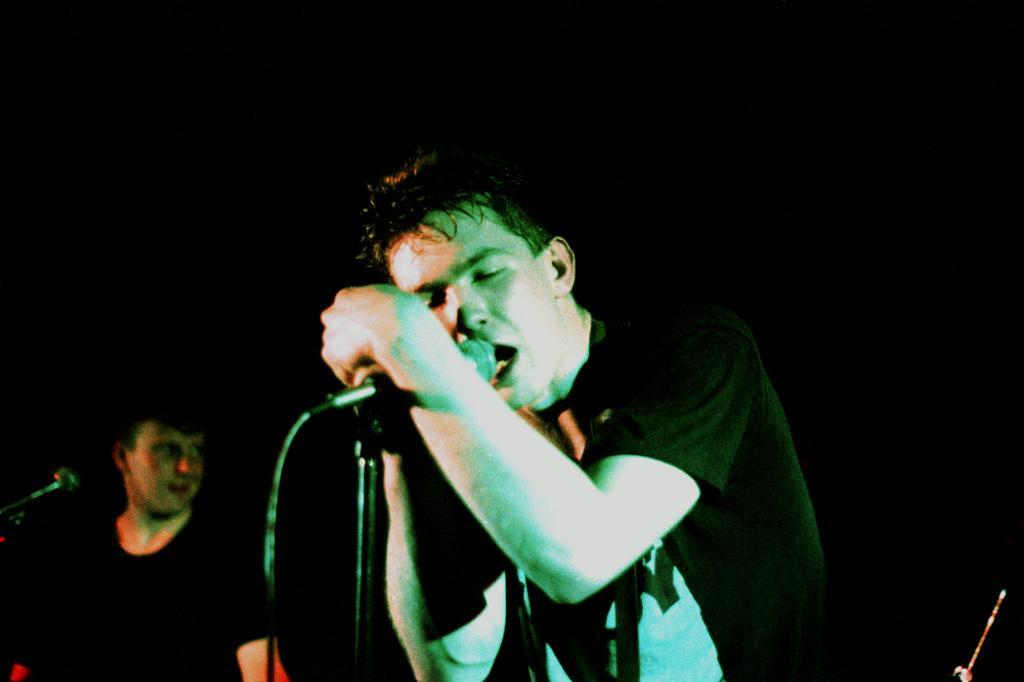Please provide a concise description of this image. This image consists of two persons. There are mikes in front of them. The one who is in the middle is singing something. 